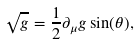<formula> <loc_0><loc_0><loc_500><loc_500>\sqrt { g } = \frac { 1 } { 2 } \partial _ { \mu } g \sin ( \theta ) ,</formula> 